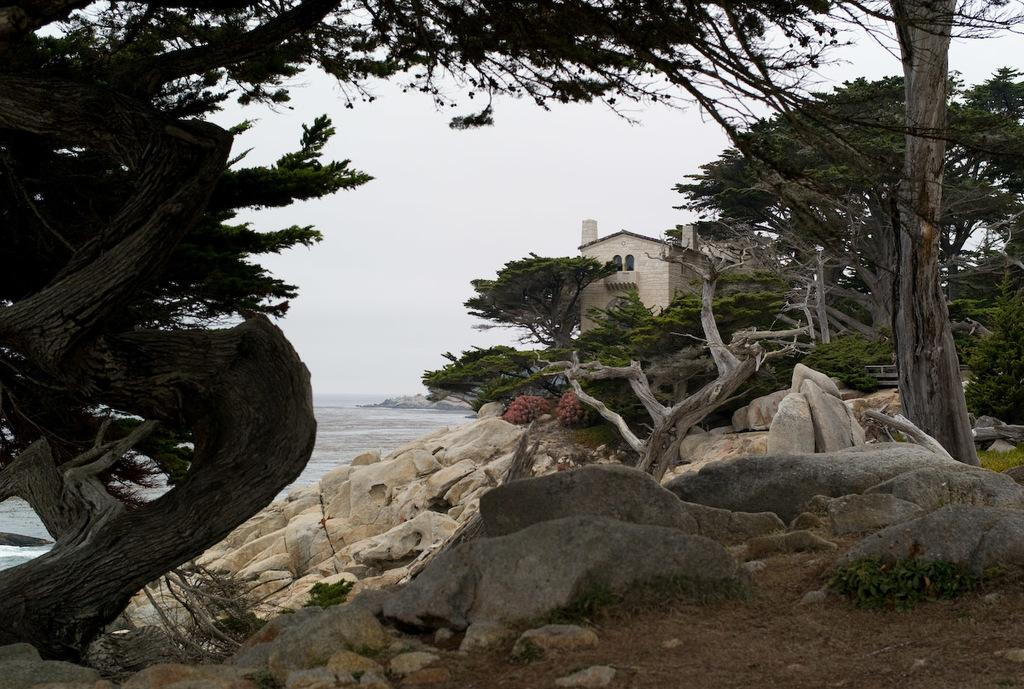What type of natural elements can be seen in the image? There are rocks and trees in the image. What type of location is depicted in the image? The image contains a beach. Are there any man-made structures visible in the image? Yes, there is a house in the image. What is visible in the background of the image? The sky is visible in the image. How many lawyers are present on the beach in the image? There are no lawyers present in the image; it features rocks, trees, a house, and the sky. What type of baby animals can be seen playing in the sand in the image? There are no baby animals present in the image; it features rocks, trees, a house, and the sky. 